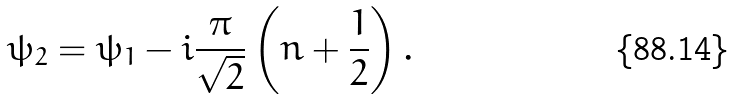<formula> <loc_0><loc_0><loc_500><loc_500>\psi _ { 2 } = \psi _ { 1 } - i \frac { \pi } { \sqrt { 2 } } \left ( n + \frac { 1 } { 2 } \right ) .</formula> 